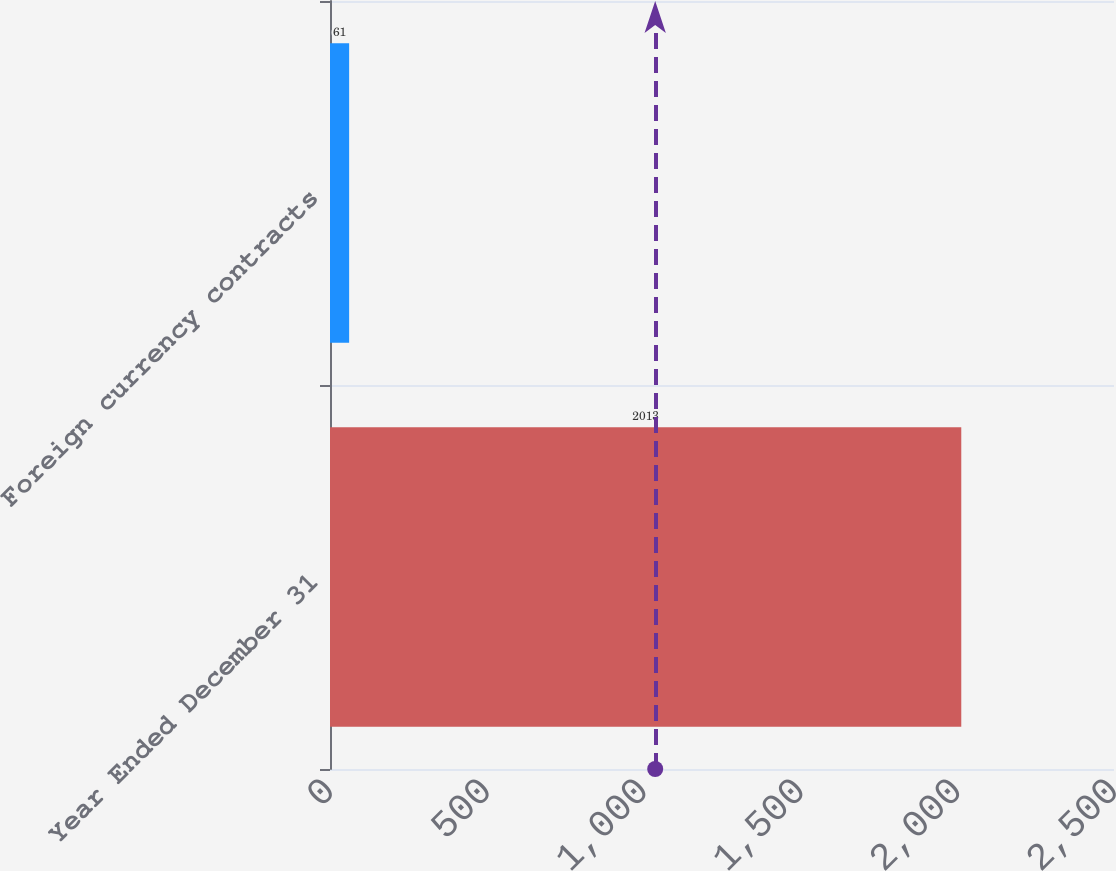Convert chart to OTSL. <chart><loc_0><loc_0><loc_500><loc_500><bar_chart><fcel>Year Ended December 31<fcel>Foreign currency contracts<nl><fcel>2013<fcel>61<nl></chart> 